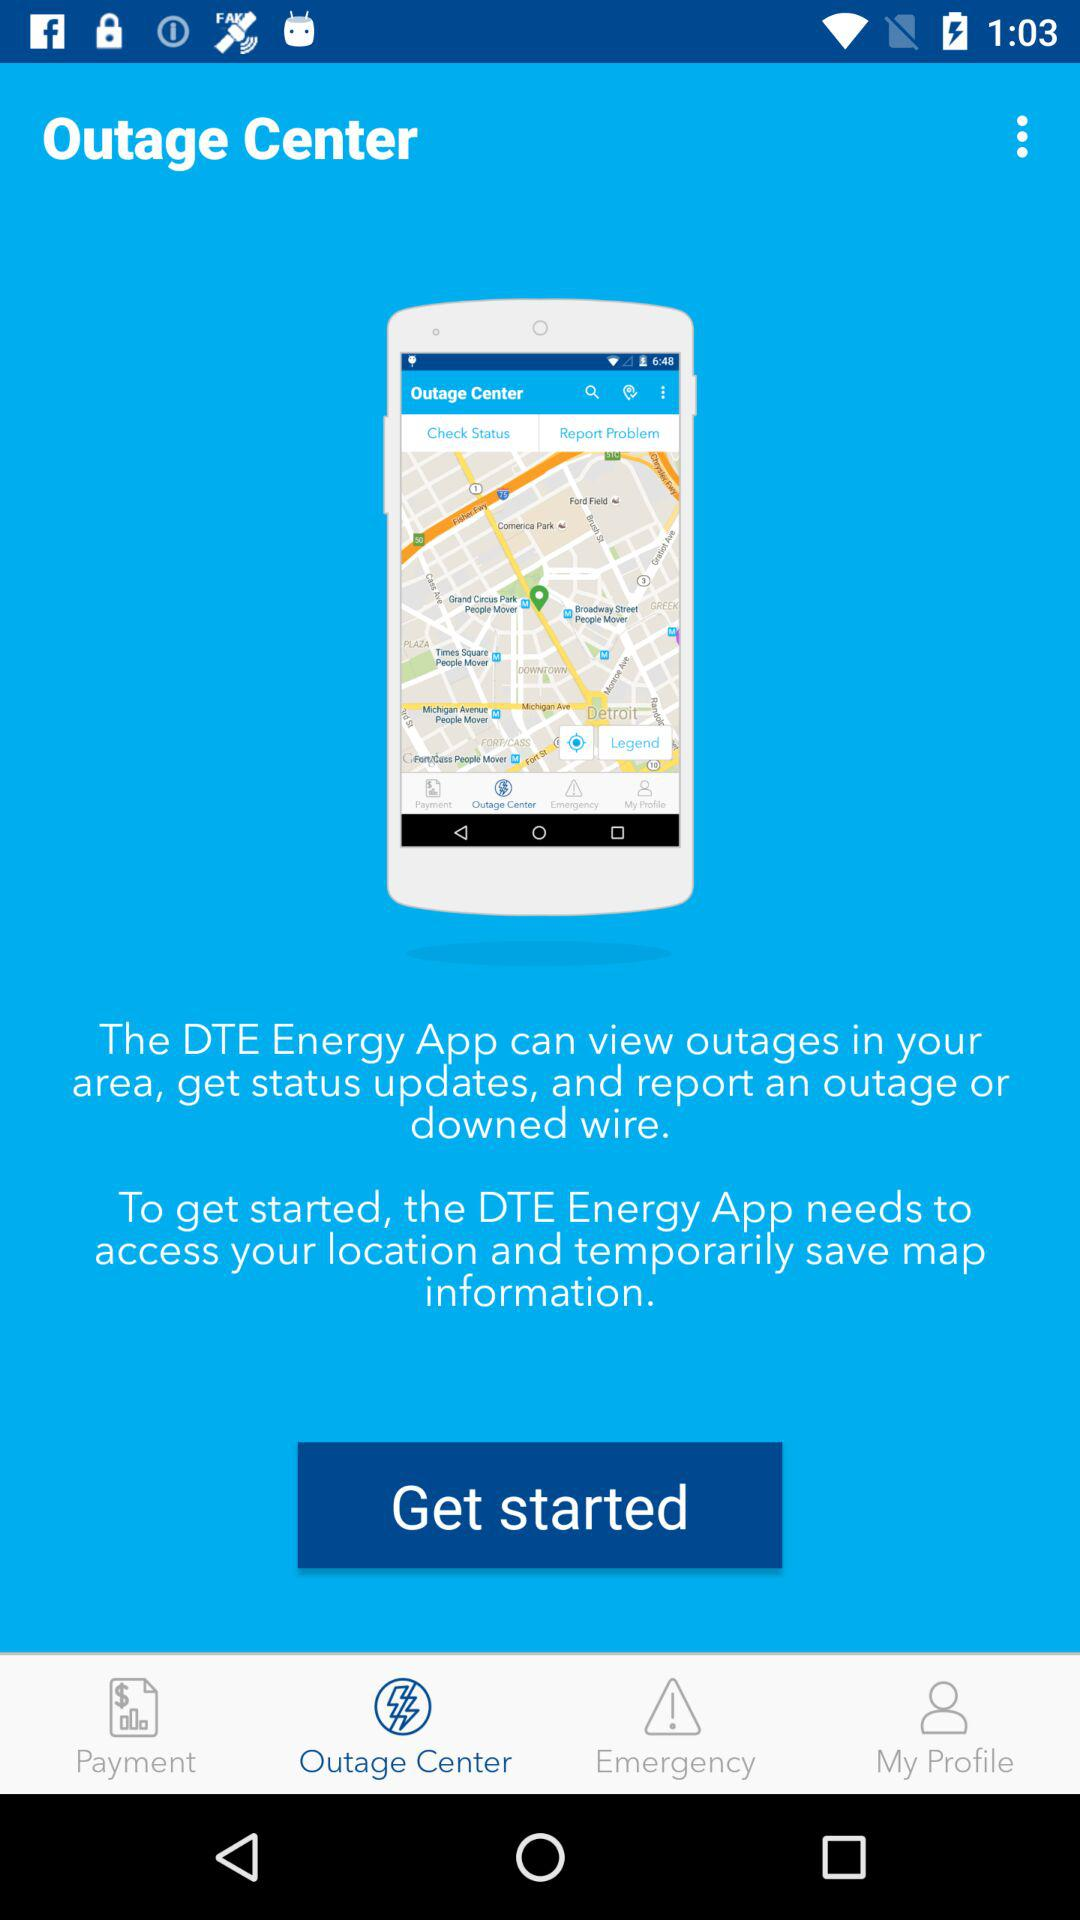Which tab is selected? The selected tab is "Outage Center". 